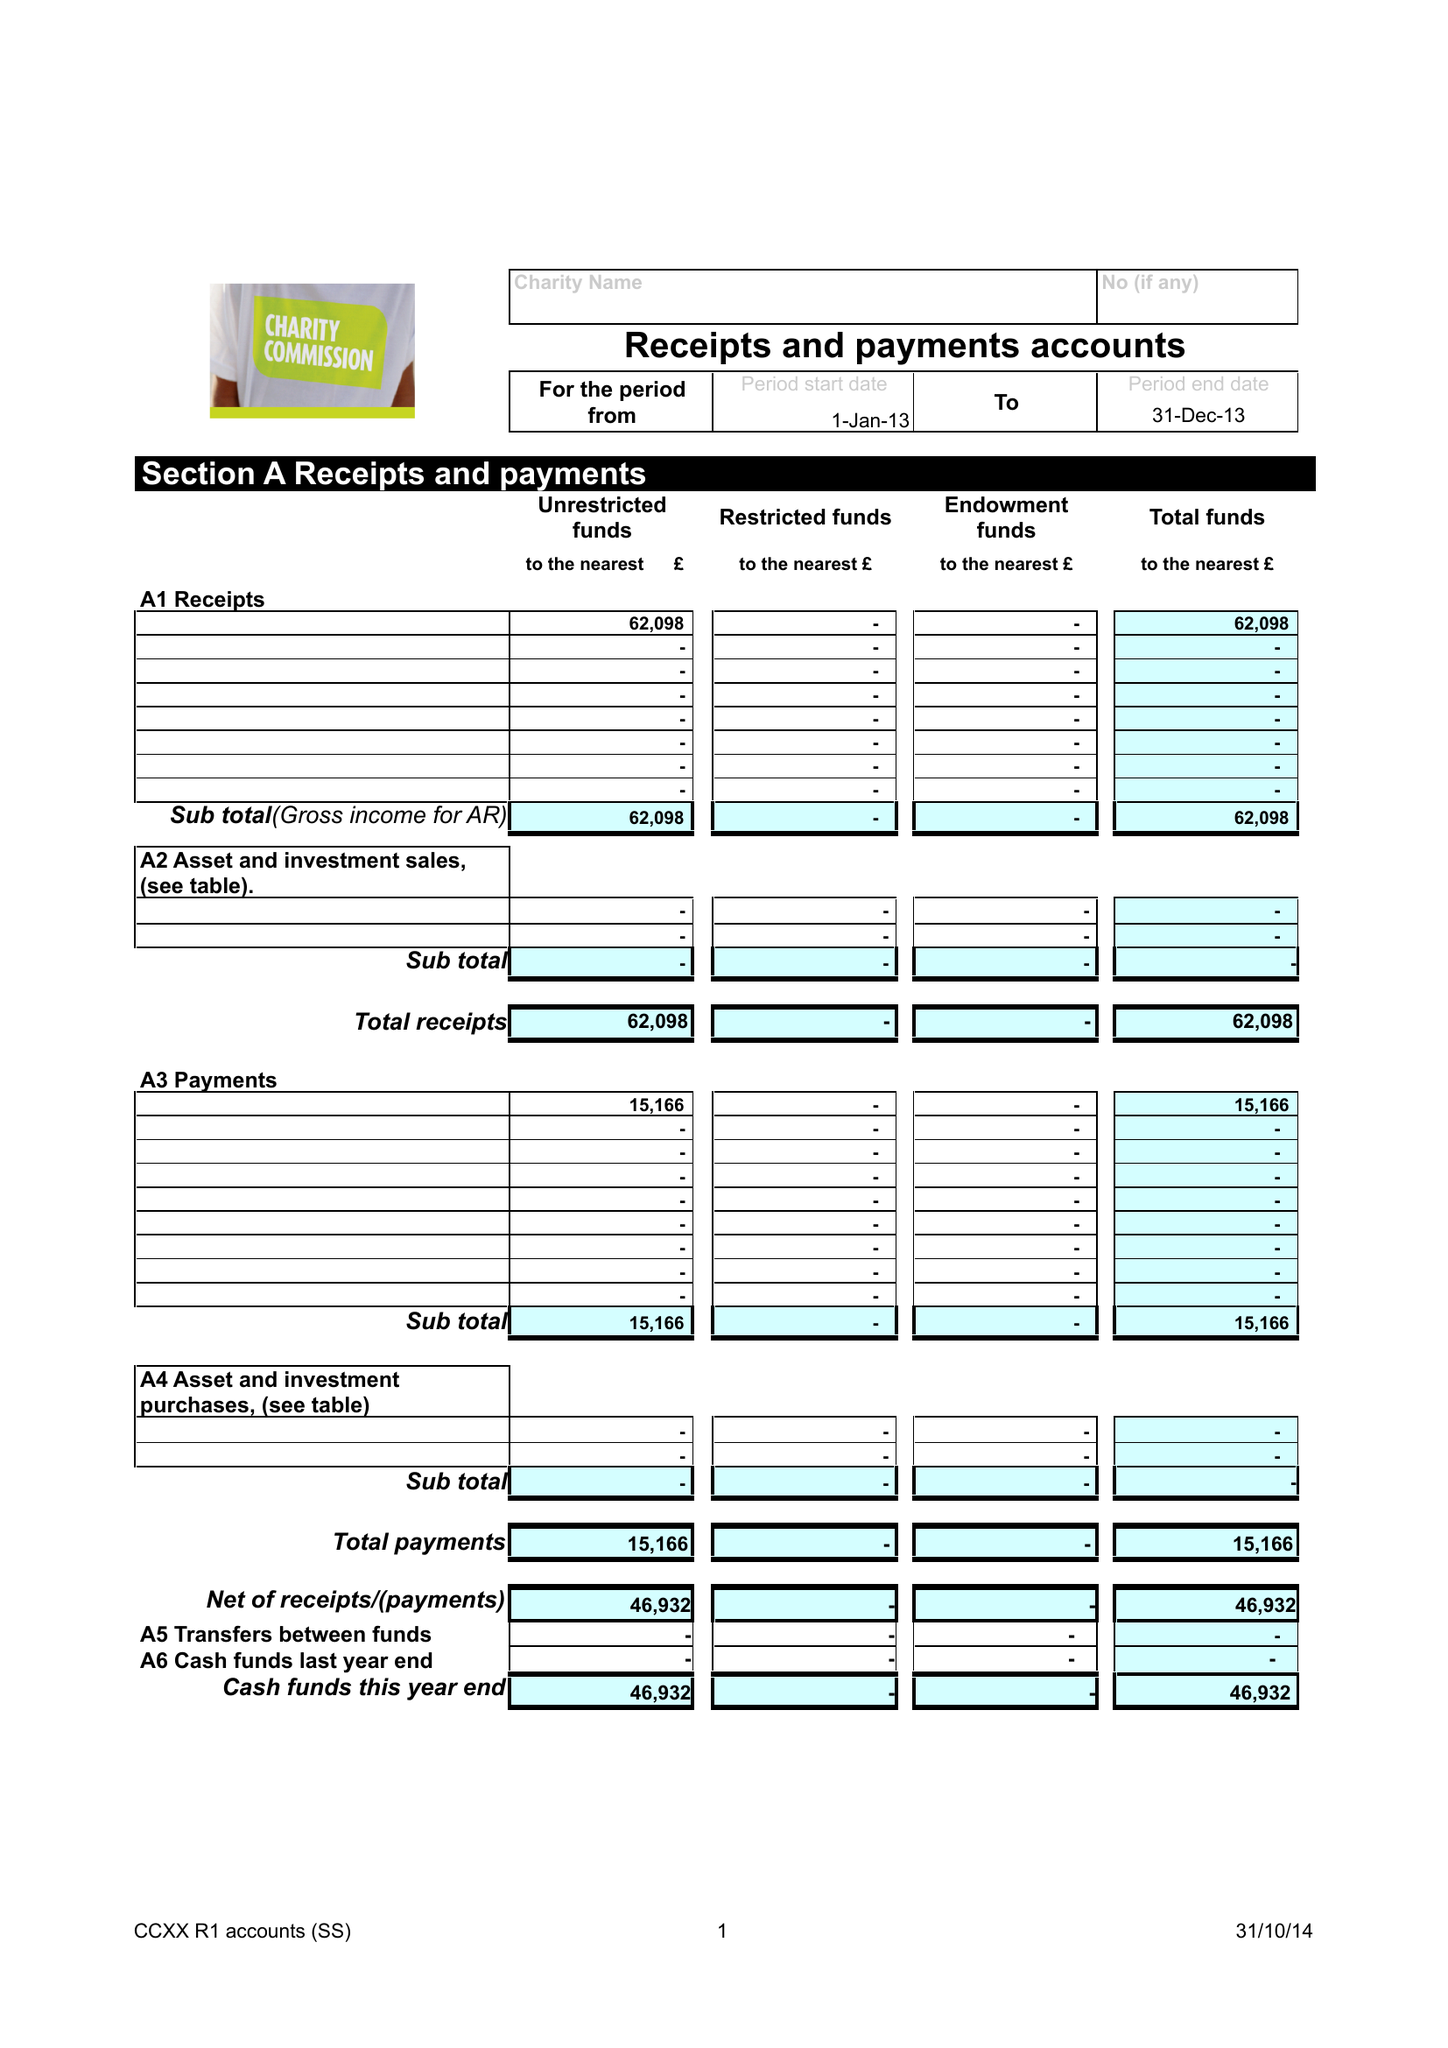What is the value for the charity_name?
Answer the question using a single word or phrase. Eglwys Efengylaidd Caerfyrddin 